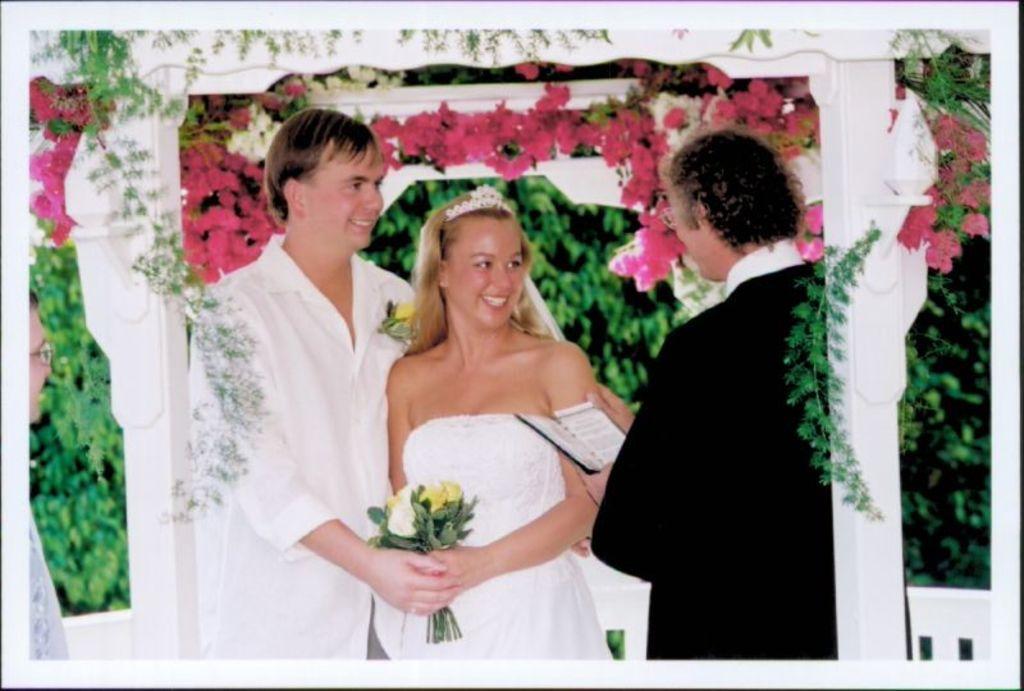Could you give a brief overview of what you see in this image? In this image we can see persons holding bouquet and book. In the background we can see flowers, trees. On the left side of the image we can see person. 